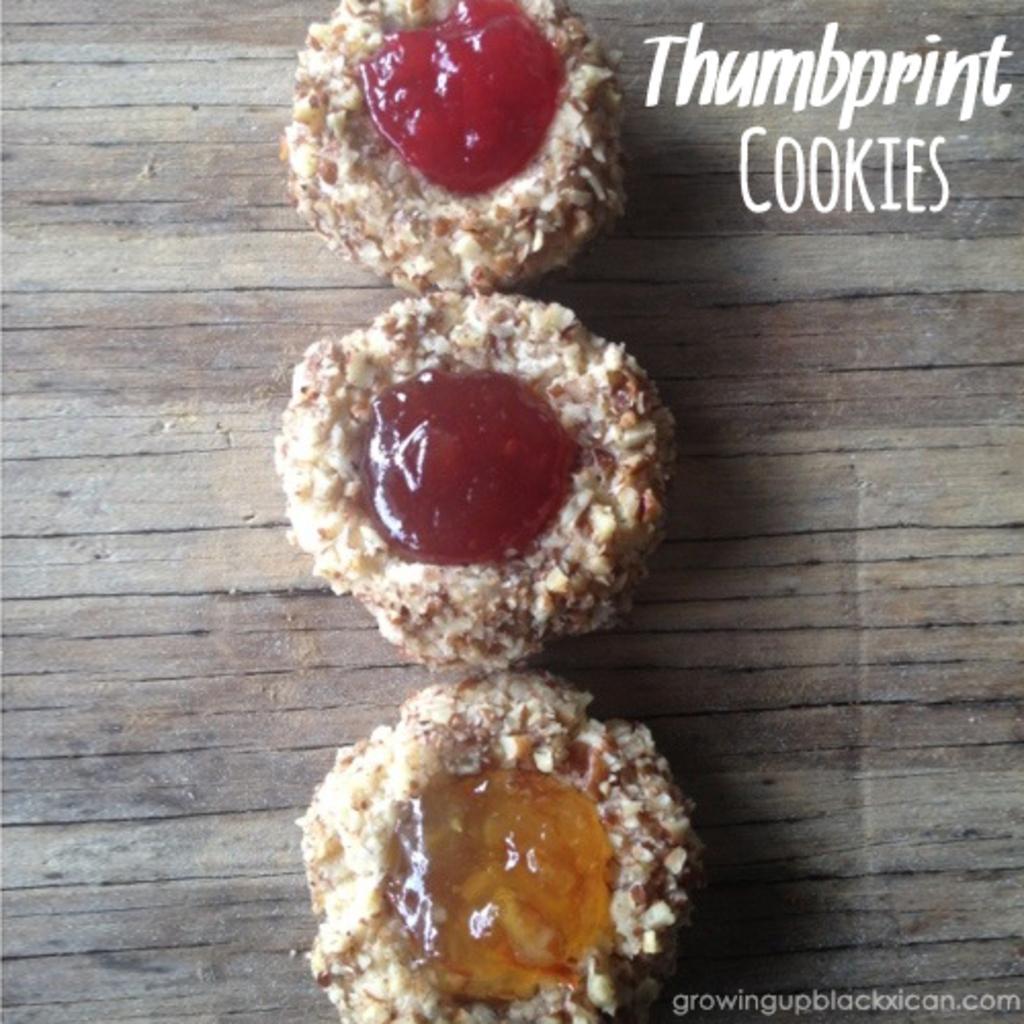How would you summarize this image in a sentence or two? This image consists of food with some text written on it. 